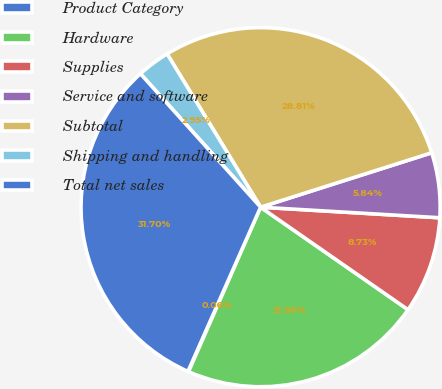<chart> <loc_0><loc_0><loc_500><loc_500><pie_chart><fcel>Product Category<fcel>Hardware<fcel>Supplies<fcel>Service and software<fcel>Subtotal<fcel>Shipping and handling<fcel>Total net sales<nl><fcel>0.06%<fcel>21.9%<fcel>8.73%<fcel>5.84%<fcel>28.81%<fcel>2.95%<fcel>31.7%<nl></chart> 